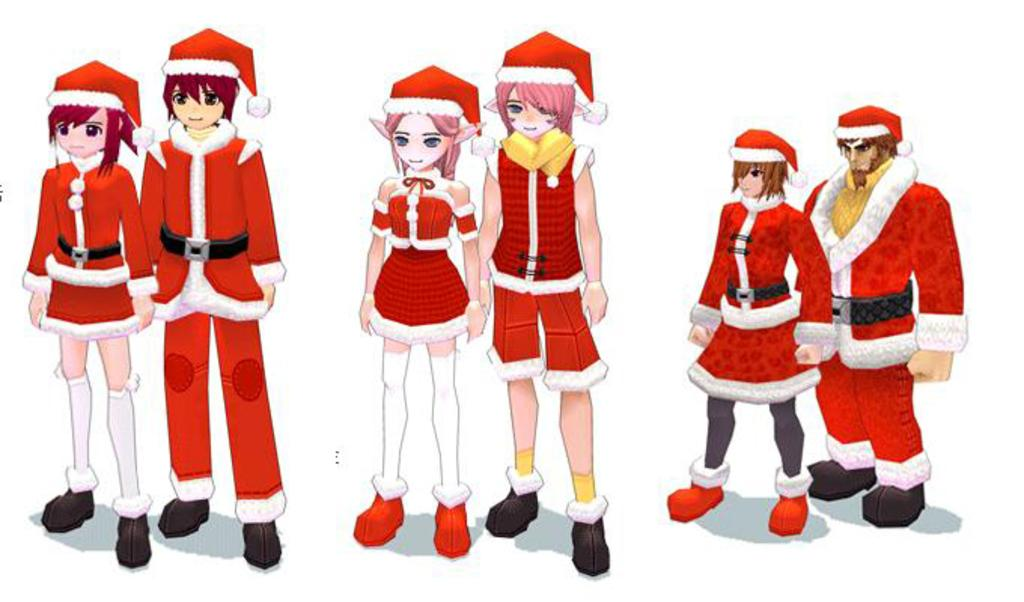How many people are present in the image? There are six people in the image. What are the people wearing in the image? All six people are wearing red color dresses. What is the color of the background in the image? The image has a white background. What type of animal can be seen interacting with the mailbox in the image? There is no animal or mailbox present in the image; it features six people wearing red color dresses against a white background. 